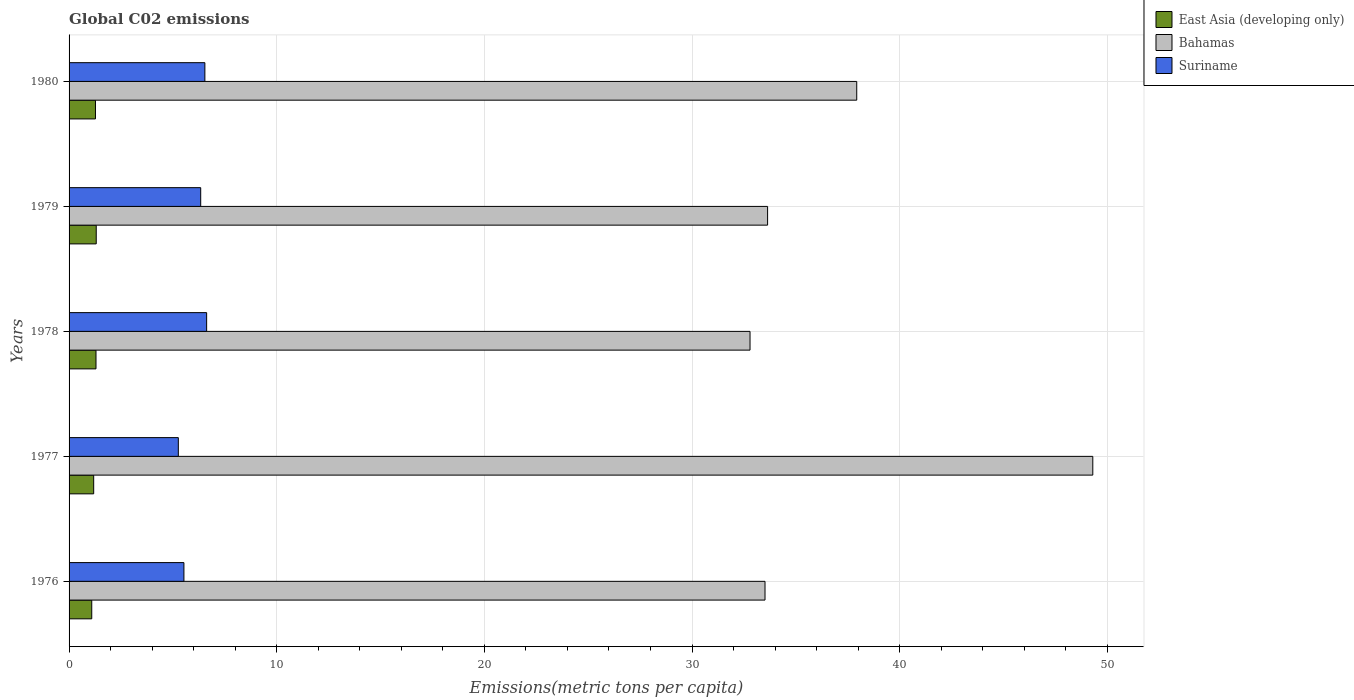How many different coloured bars are there?
Offer a terse response. 3. How many groups of bars are there?
Provide a short and direct response. 5. What is the label of the 2nd group of bars from the top?
Your response must be concise. 1979. What is the amount of CO2 emitted in in Bahamas in 1978?
Your answer should be very brief. 32.79. Across all years, what is the maximum amount of CO2 emitted in in Suriname?
Offer a very short reply. 6.62. Across all years, what is the minimum amount of CO2 emitted in in Bahamas?
Your answer should be very brief. 32.79. In which year was the amount of CO2 emitted in in East Asia (developing only) maximum?
Make the answer very short. 1979. In which year was the amount of CO2 emitted in in Bahamas minimum?
Provide a short and direct response. 1978. What is the total amount of CO2 emitted in in Suriname in the graph?
Provide a succinct answer. 30.29. What is the difference between the amount of CO2 emitted in in Suriname in 1977 and that in 1980?
Provide a succinct answer. -1.28. What is the difference between the amount of CO2 emitted in in Bahamas in 1979 and the amount of CO2 emitted in in East Asia (developing only) in 1976?
Ensure brevity in your answer.  32.55. What is the average amount of CO2 emitted in in Suriname per year?
Give a very brief answer. 6.06. In the year 1980, what is the difference between the amount of CO2 emitted in in Suriname and amount of CO2 emitted in in East Asia (developing only)?
Offer a terse response. 5.27. What is the ratio of the amount of CO2 emitted in in East Asia (developing only) in 1979 to that in 1980?
Your answer should be very brief. 1.03. Is the amount of CO2 emitted in in Suriname in 1978 less than that in 1979?
Offer a terse response. No. What is the difference between the highest and the second highest amount of CO2 emitted in in Bahamas?
Your answer should be compact. 11.37. What is the difference between the highest and the lowest amount of CO2 emitted in in Bahamas?
Make the answer very short. 16.51. Is the sum of the amount of CO2 emitted in in Bahamas in 1977 and 1978 greater than the maximum amount of CO2 emitted in in East Asia (developing only) across all years?
Provide a succinct answer. Yes. What does the 1st bar from the top in 1979 represents?
Your answer should be very brief. Suriname. What does the 3rd bar from the bottom in 1976 represents?
Your answer should be very brief. Suriname. Are all the bars in the graph horizontal?
Provide a succinct answer. Yes. How many years are there in the graph?
Your response must be concise. 5. Where does the legend appear in the graph?
Your answer should be compact. Top right. How many legend labels are there?
Provide a short and direct response. 3. How are the legend labels stacked?
Provide a short and direct response. Vertical. What is the title of the graph?
Your answer should be very brief. Global C02 emissions. What is the label or title of the X-axis?
Provide a succinct answer. Emissions(metric tons per capita). What is the label or title of the Y-axis?
Offer a terse response. Years. What is the Emissions(metric tons per capita) of East Asia (developing only) in 1976?
Give a very brief answer. 1.09. What is the Emissions(metric tons per capita) in Bahamas in 1976?
Provide a short and direct response. 33.51. What is the Emissions(metric tons per capita) in Suriname in 1976?
Give a very brief answer. 5.53. What is the Emissions(metric tons per capita) in East Asia (developing only) in 1977?
Your answer should be compact. 1.19. What is the Emissions(metric tons per capita) in Bahamas in 1977?
Make the answer very short. 49.3. What is the Emissions(metric tons per capita) in Suriname in 1977?
Offer a very short reply. 5.26. What is the Emissions(metric tons per capita) in East Asia (developing only) in 1978?
Keep it short and to the point. 1.3. What is the Emissions(metric tons per capita) of Bahamas in 1978?
Make the answer very short. 32.79. What is the Emissions(metric tons per capita) in Suriname in 1978?
Give a very brief answer. 6.62. What is the Emissions(metric tons per capita) of East Asia (developing only) in 1979?
Keep it short and to the point. 1.31. What is the Emissions(metric tons per capita) in Bahamas in 1979?
Keep it short and to the point. 33.64. What is the Emissions(metric tons per capita) of Suriname in 1979?
Make the answer very short. 6.34. What is the Emissions(metric tons per capita) of East Asia (developing only) in 1980?
Ensure brevity in your answer.  1.27. What is the Emissions(metric tons per capita) of Bahamas in 1980?
Your response must be concise. 37.93. What is the Emissions(metric tons per capita) in Suriname in 1980?
Make the answer very short. 6.54. Across all years, what is the maximum Emissions(metric tons per capita) of East Asia (developing only)?
Your response must be concise. 1.31. Across all years, what is the maximum Emissions(metric tons per capita) in Bahamas?
Make the answer very short. 49.3. Across all years, what is the maximum Emissions(metric tons per capita) of Suriname?
Give a very brief answer. 6.62. Across all years, what is the minimum Emissions(metric tons per capita) in East Asia (developing only)?
Keep it short and to the point. 1.09. Across all years, what is the minimum Emissions(metric tons per capita) in Bahamas?
Your answer should be compact. 32.79. Across all years, what is the minimum Emissions(metric tons per capita) in Suriname?
Make the answer very short. 5.26. What is the total Emissions(metric tons per capita) in East Asia (developing only) in the graph?
Your answer should be compact. 6.15. What is the total Emissions(metric tons per capita) in Bahamas in the graph?
Keep it short and to the point. 187.17. What is the total Emissions(metric tons per capita) of Suriname in the graph?
Provide a short and direct response. 30.29. What is the difference between the Emissions(metric tons per capita) in East Asia (developing only) in 1976 and that in 1977?
Your response must be concise. -0.09. What is the difference between the Emissions(metric tons per capita) in Bahamas in 1976 and that in 1977?
Offer a very short reply. -15.78. What is the difference between the Emissions(metric tons per capita) of Suriname in 1976 and that in 1977?
Your answer should be very brief. 0.27. What is the difference between the Emissions(metric tons per capita) in East Asia (developing only) in 1976 and that in 1978?
Ensure brevity in your answer.  -0.2. What is the difference between the Emissions(metric tons per capita) in Bahamas in 1976 and that in 1978?
Provide a succinct answer. 0.72. What is the difference between the Emissions(metric tons per capita) of Suriname in 1976 and that in 1978?
Your answer should be compact. -1.09. What is the difference between the Emissions(metric tons per capita) of East Asia (developing only) in 1976 and that in 1979?
Your answer should be compact. -0.22. What is the difference between the Emissions(metric tons per capita) in Bahamas in 1976 and that in 1979?
Make the answer very short. -0.12. What is the difference between the Emissions(metric tons per capita) of Suriname in 1976 and that in 1979?
Provide a short and direct response. -0.81. What is the difference between the Emissions(metric tons per capita) in East Asia (developing only) in 1976 and that in 1980?
Ensure brevity in your answer.  -0.18. What is the difference between the Emissions(metric tons per capita) of Bahamas in 1976 and that in 1980?
Offer a very short reply. -4.42. What is the difference between the Emissions(metric tons per capita) in Suriname in 1976 and that in 1980?
Keep it short and to the point. -1.01. What is the difference between the Emissions(metric tons per capita) of East Asia (developing only) in 1977 and that in 1978?
Ensure brevity in your answer.  -0.11. What is the difference between the Emissions(metric tons per capita) in Bahamas in 1977 and that in 1978?
Offer a terse response. 16.51. What is the difference between the Emissions(metric tons per capita) of Suriname in 1977 and that in 1978?
Keep it short and to the point. -1.36. What is the difference between the Emissions(metric tons per capita) in East Asia (developing only) in 1977 and that in 1979?
Your answer should be very brief. -0.12. What is the difference between the Emissions(metric tons per capita) in Bahamas in 1977 and that in 1979?
Your answer should be compact. 15.66. What is the difference between the Emissions(metric tons per capita) in Suriname in 1977 and that in 1979?
Your answer should be very brief. -1.08. What is the difference between the Emissions(metric tons per capita) in East Asia (developing only) in 1977 and that in 1980?
Offer a very short reply. -0.09. What is the difference between the Emissions(metric tons per capita) of Bahamas in 1977 and that in 1980?
Ensure brevity in your answer.  11.37. What is the difference between the Emissions(metric tons per capita) of Suriname in 1977 and that in 1980?
Your response must be concise. -1.28. What is the difference between the Emissions(metric tons per capita) in East Asia (developing only) in 1978 and that in 1979?
Your answer should be very brief. -0.01. What is the difference between the Emissions(metric tons per capita) in Bahamas in 1978 and that in 1979?
Provide a short and direct response. -0.85. What is the difference between the Emissions(metric tons per capita) in Suriname in 1978 and that in 1979?
Offer a terse response. 0.29. What is the difference between the Emissions(metric tons per capita) in East Asia (developing only) in 1978 and that in 1980?
Provide a short and direct response. 0.03. What is the difference between the Emissions(metric tons per capita) of Bahamas in 1978 and that in 1980?
Offer a very short reply. -5.14. What is the difference between the Emissions(metric tons per capita) of Suriname in 1978 and that in 1980?
Your answer should be compact. 0.08. What is the difference between the Emissions(metric tons per capita) of East Asia (developing only) in 1979 and that in 1980?
Your answer should be very brief. 0.04. What is the difference between the Emissions(metric tons per capita) in Bahamas in 1979 and that in 1980?
Give a very brief answer. -4.29. What is the difference between the Emissions(metric tons per capita) in Suriname in 1979 and that in 1980?
Give a very brief answer. -0.2. What is the difference between the Emissions(metric tons per capita) in East Asia (developing only) in 1976 and the Emissions(metric tons per capita) in Bahamas in 1977?
Your answer should be very brief. -48.21. What is the difference between the Emissions(metric tons per capita) of East Asia (developing only) in 1976 and the Emissions(metric tons per capita) of Suriname in 1977?
Provide a succinct answer. -4.17. What is the difference between the Emissions(metric tons per capita) in Bahamas in 1976 and the Emissions(metric tons per capita) in Suriname in 1977?
Ensure brevity in your answer.  28.25. What is the difference between the Emissions(metric tons per capita) of East Asia (developing only) in 1976 and the Emissions(metric tons per capita) of Bahamas in 1978?
Provide a succinct answer. -31.7. What is the difference between the Emissions(metric tons per capita) of East Asia (developing only) in 1976 and the Emissions(metric tons per capita) of Suriname in 1978?
Offer a very short reply. -5.53. What is the difference between the Emissions(metric tons per capita) in Bahamas in 1976 and the Emissions(metric tons per capita) in Suriname in 1978?
Make the answer very short. 26.89. What is the difference between the Emissions(metric tons per capita) in East Asia (developing only) in 1976 and the Emissions(metric tons per capita) in Bahamas in 1979?
Your answer should be very brief. -32.55. What is the difference between the Emissions(metric tons per capita) of East Asia (developing only) in 1976 and the Emissions(metric tons per capita) of Suriname in 1979?
Ensure brevity in your answer.  -5.25. What is the difference between the Emissions(metric tons per capita) of Bahamas in 1976 and the Emissions(metric tons per capita) of Suriname in 1979?
Give a very brief answer. 27.17. What is the difference between the Emissions(metric tons per capita) of East Asia (developing only) in 1976 and the Emissions(metric tons per capita) of Bahamas in 1980?
Your answer should be very brief. -36.84. What is the difference between the Emissions(metric tons per capita) of East Asia (developing only) in 1976 and the Emissions(metric tons per capita) of Suriname in 1980?
Provide a succinct answer. -5.45. What is the difference between the Emissions(metric tons per capita) in Bahamas in 1976 and the Emissions(metric tons per capita) in Suriname in 1980?
Provide a short and direct response. 26.97. What is the difference between the Emissions(metric tons per capita) of East Asia (developing only) in 1977 and the Emissions(metric tons per capita) of Bahamas in 1978?
Your answer should be compact. -31.61. What is the difference between the Emissions(metric tons per capita) in East Asia (developing only) in 1977 and the Emissions(metric tons per capita) in Suriname in 1978?
Make the answer very short. -5.44. What is the difference between the Emissions(metric tons per capita) of Bahamas in 1977 and the Emissions(metric tons per capita) of Suriname in 1978?
Your answer should be very brief. 42.67. What is the difference between the Emissions(metric tons per capita) in East Asia (developing only) in 1977 and the Emissions(metric tons per capita) in Bahamas in 1979?
Keep it short and to the point. -32.45. What is the difference between the Emissions(metric tons per capita) of East Asia (developing only) in 1977 and the Emissions(metric tons per capita) of Suriname in 1979?
Keep it short and to the point. -5.15. What is the difference between the Emissions(metric tons per capita) of Bahamas in 1977 and the Emissions(metric tons per capita) of Suriname in 1979?
Provide a short and direct response. 42.96. What is the difference between the Emissions(metric tons per capita) of East Asia (developing only) in 1977 and the Emissions(metric tons per capita) of Bahamas in 1980?
Ensure brevity in your answer.  -36.75. What is the difference between the Emissions(metric tons per capita) of East Asia (developing only) in 1977 and the Emissions(metric tons per capita) of Suriname in 1980?
Your answer should be very brief. -5.35. What is the difference between the Emissions(metric tons per capita) of Bahamas in 1977 and the Emissions(metric tons per capita) of Suriname in 1980?
Ensure brevity in your answer.  42.76. What is the difference between the Emissions(metric tons per capita) in East Asia (developing only) in 1978 and the Emissions(metric tons per capita) in Bahamas in 1979?
Offer a very short reply. -32.34. What is the difference between the Emissions(metric tons per capita) of East Asia (developing only) in 1978 and the Emissions(metric tons per capita) of Suriname in 1979?
Ensure brevity in your answer.  -5.04. What is the difference between the Emissions(metric tons per capita) of Bahamas in 1978 and the Emissions(metric tons per capita) of Suriname in 1979?
Offer a terse response. 26.45. What is the difference between the Emissions(metric tons per capita) in East Asia (developing only) in 1978 and the Emissions(metric tons per capita) in Bahamas in 1980?
Your response must be concise. -36.63. What is the difference between the Emissions(metric tons per capita) in East Asia (developing only) in 1978 and the Emissions(metric tons per capita) in Suriname in 1980?
Make the answer very short. -5.24. What is the difference between the Emissions(metric tons per capita) of Bahamas in 1978 and the Emissions(metric tons per capita) of Suriname in 1980?
Ensure brevity in your answer.  26.25. What is the difference between the Emissions(metric tons per capita) of East Asia (developing only) in 1979 and the Emissions(metric tons per capita) of Bahamas in 1980?
Provide a short and direct response. -36.62. What is the difference between the Emissions(metric tons per capita) in East Asia (developing only) in 1979 and the Emissions(metric tons per capita) in Suriname in 1980?
Keep it short and to the point. -5.23. What is the difference between the Emissions(metric tons per capita) of Bahamas in 1979 and the Emissions(metric tons per capita) of Suriname in 1980?
Give a very brief answer. 27.1. What is the average Emissions(metric tons per capita) in East Asia (developing only) per year?
Your answer should be compact. 1.23. What is the average Emissions(metric tons per capita) in Bahamas per year?
Ensure brevity in your answer.  37.43. What is the average Emissions(metric tons per capita) in Suriname per year?
Provide a succinct answer. 6.06. In the year 1976, what is the difference between the Emissions(metric tons per capita) in East Asia (developing only) and Emissions(metric tons per capita) in Bahamas?
Make the answer very short. -32.42. In the year 1976, what is the difference between the Emissions(metric tons per capita) in East Asia (developing only) and Emissions(metric tons per capita) in Suriname?
Offer a terse response. -4.44. In the year 1976, what is the difference between the Emissions(metric tons per capita) in Bahamas and Emissions(metric tons per capita) in Suriname?
Provide a short and direct response. 27.98. In the year 1977, what is the difference between the Emissions(metric tons per capita) in East Asia (developing only) and Emissions(metric tons per capita) in Bahamas?
Provide a succinct answer. -48.11. In the year 1977, what is the difference between the Emissions(metric tons per capita) of East Asia (developing only) and Emissions(metric tons per capita) of Suriname?
Offer a terse response. -4.08. In the year 1977, what is the difference between the Emissions(metric tons per capita) in Bahamas and Emissions(metric tons per capita) in Suriname?
Your response must be concise. 44.04. In the year 1978, what is the difference between the Emissions(metric tons per capita) in East Asia (developing only) and Emissions(metric tons per capita) in Bahamas?
Offer a very short reply. -31.5. In the year 1978, what is the difference between the Emissions(metric tons per capita) in East Asia (developing only) and Emissions(metric tons per capita) in Suriname?
Give a very brief answer. -5.33. In the year 1978, what is the difference between the Emissions(metric tons per capita) of Bahamas and Emissions(metric tons per capita) of Suriname?
Your answer should be very brief. 26.17. In the year 1979, what is the difference between the Emissions(metric tons per capita) of East Asia (developing only) and Emissions(metric tons per capita) of Bahamas?
Your answer should be compact. -32.33. In the year 1979, what is the difference between the Emissions(metric tons per capita) in East Asia (developing only) and Emissions(metric tons per capita) in Suriname?
Your answer should be very brief. -5.03. In the year 1979, what is the difference between the Emissions(metric tons per capita) of Bahamas and Emissions(metric tons per capita) of Suriname?
Your answer should be compact. 27.3. In the year 1980, what is the difference between the Emissions(metric tons per capita) in East Asia (developing only) and Emissions(metric tons per capita) in Bahamas?
Offer a very short reply. -36.66. In the year 1980, what is the difference between the Emissions(metric tons per capita) in East Asia (developing only) and Emissions(metric tons per capita) in Suriname?
Offer a very short reply. -5.27. In the year 1980, what is the difference between the Emissions(metric tons per capita) of Bahamas and Emissions(metric tons per capita) of Suriname?
Provide a short and direct response. 31.39. What is the ratio of the Emissions(metric tons per capita) of East Asia (developing only) in 1976 to that in 1977?
Make the answer very short. 0.92. What is the ratio of the Emissions(metric tons per capita) of Bahamas in 1976 to that in 1977?
Ensure brevity in your answer.  0.68. What is the ratio of the Emissions(metric tons per capita) in Suriname in 1976 to that in 1977?
Give a very brief answer. 1.05. What is the ratio of the Emissions(metric tons per capita) of East Asia (developing only) in 1976 to that in 1978?
Provide a short and direct response. 0.84. What is the ratio of the Emissions(metric tons per capita) of Suriname in 1976 to that in 1978?
Your answer should be compact. 0.83. What is the ratio of the Emissions(metric tons per capita) in East Asia (developing only) in 1976 to that in 1979?
Make the answer very short. 0.83. What is the ratio of the Emissions(metric tons per capita) of Bahamas in 1976 to that in 1979?
Make the answer very short. 1. What is the ratio of the Emissions(metric tons per capita) in Suriname in 1976 to that in 1979?
Give a very brief answer. 0.87. What is the ratio of the Emissions(metric tons per capita) in East Asia (developing only) in 1976 to that in 1980?
Offer a very short reply. 0.86. What is the ratio of the Emissions(metric tons per capita) in Bahamas in 1976 to that in 1980?
Offer a terse response. 0.88. What is the ratio of the Emissions(metric tons per capita) in Suriname in 1976 to that in 1980?
Your answer should be compact. 0.85. What is the ratio of the Emissions(metric tons per capita) of East Asia (developing only) in 1977 to that in 1978?
Give a very brief answer. 0.91. What is the ratio of the Emissions(metric tons per capita) in Bahamas in 1977 to that in 1978?
Your response must be concise. 1.5. What is the ratio of the Emissions(metric tons per capita) of Suriname in 1977 to that in 1978?
Your answer should be compact. 0.79. What is the ratio of the Emissions(metric tons per capita) of East Asia (developing only) in 1977 to that in 1979?
Make the answer very short. 0.91. What is the ratio of the Emissions(metric tons per capita) in Bahamas in 1977 to that in 1979?
Offer a very short reply. 1.47. What is the ratio of the Emissions(metric tons per capita) of Suriname in 1977 to that in 1979?
Ensure brevity in your answer.  0.83. What is the ratio of the Emissions(metric tons per capita) in East Asia (developing only) in 1977 to that in 1980?
Your response must be concise. 0.93. What is the ratio of the Emissions(metric tons per capita) in Bahamas in 1977 to that in 1980?
Offer a very short reply. 1.3. What is the ratio of the Emissions(metric tons per capita) of Suriname in 1977 to that in 1980?
Make the answer very short. 0.8. What is the ratio of the Emissions(metric tons per capita) of Bahamas in 1978 to that in 1979?
Provide a succinct answer. 0.97. What is the ratio of the Emissions(metric tons per capita) of Suriname in 1978 to that in 1979?
Provide a succinct answer. 1.05. What is the ratio of the Emissions(metric tons per capita) of East Asia (developing only) in 1978 to that in 1980?
Provide a succinct answer. 1.02. What is the ratio of the Emissions(metric tons per capita) of Bahamas in 1978 to that in 1980?
Your answer should be very brief. 0.86. What is the ratio of the Emissions(metric tons per capita) of Suriname in 1978 to that in 1980?
Your response must be concise. 1.01. What is the ratio of the Emissions(metric tons per capita) of East Asia (developing only) in 1979 to that in 1980?
Offer a terse response. 1.03. What is the ratio of the Emissions(metric tons per capita) in Bahamas in 1979 to that in 1980?
Provide a short and direct response. 0.89. What is the ratio of the Emissions(metric tons per capita) in Suriname in 1979 to that in 1980?
Provide a succinct answer. 0.97. What is the difference between the highest and the second highest Emissions(metric tons per capita) in East Asia (developing only)?
Give a very brief answer. 0.01. What is the difference between the highest and the second highest Emissions(metric tons per capita) of Bahamas?
Give a very brief answer. 11.37. What is the difference between the highest and the second highest Emissions(metric tons per capita) of Suriname?
Give a very brief answer. 0.08. What is the difference between the highest and the lowest Emissions(metric tons per capita) of East Asia (developing only)?
Give a very brief answer. 0.22. What is the difference between the highest and the lowest Emissions(metric tons per capita) in Bahamas?
Your response must be concise. 16.51. What is the difference between the highest and the lowest Emissions(metric tons per capita) in Suriname?
Make the answer very short. 1.36. 